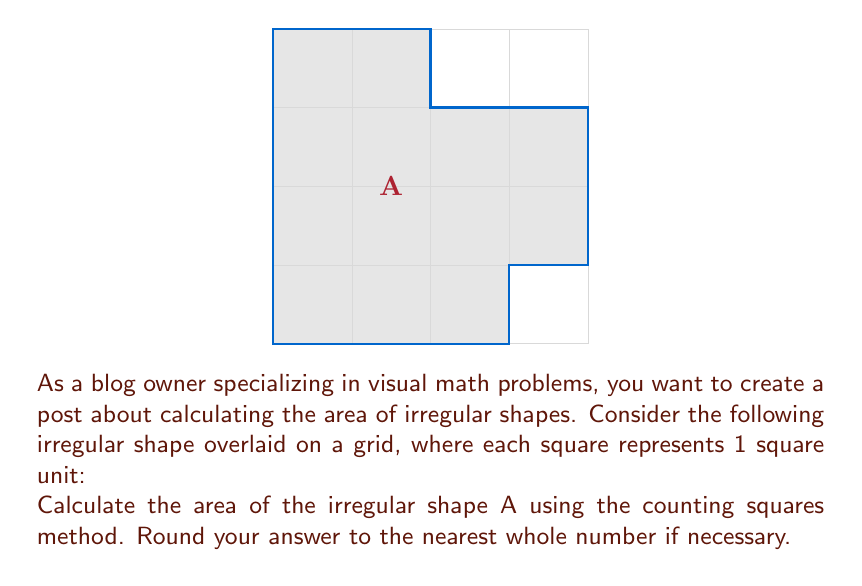What is the answer to this math problem? To calculate the area of the irregular shape using the grid method, we need to:

1. Count the number of whole squares within the shape.
2. Estimate the fractional parts of squares along the edges.
3. Sum up the whole and fractional parts.

Step 1: Counting whole squares
- There are 8 whole squares fully contained within the shape.

Step 2: Estimating fractional parts
- Top edge: approximately 1/2 square
- Right edge: approximately 1/2 square
- Bottom-right corner: approximately 1/4 square
- Bottom-left corner: approximately 1/4 square

Step 3: Summing up
$$\text{Total Area} = \text{Whole squares} + \text{Fractional parts}$$
$$\text{Total Area} = 8 + (0.5 + 0.5 + 0.25 + 0.25)$$
$$\text{Total Area} = 8 + 1.5 = 9.5 \text{ square units}$$

Rounding to the nearest whole number:
$$\text{Area} \approx 10 \text{ square units}$$
Answer: 10 square units 